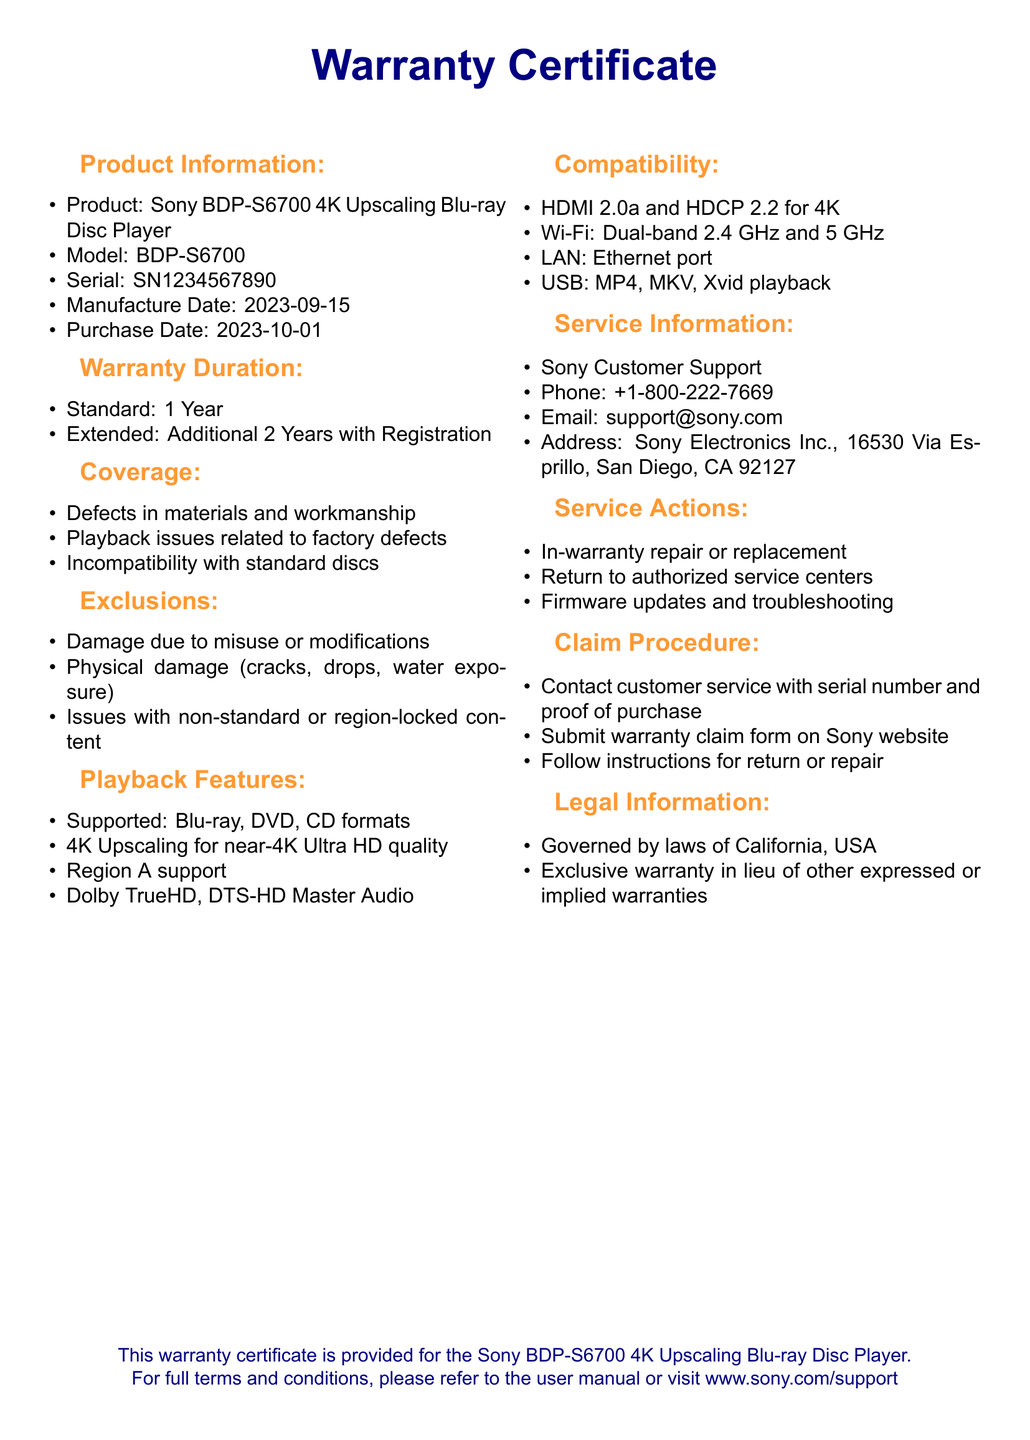What is the product name? The product name is specified in the "Product Information" section as the Sony BDP-S6700 4K Upscaling Blu-ray Disc Player.
Answer: Sony BDP-S6700 4K Upscaling Blu-ray Disc Player What is the warranty duration for the standard warranty? The warranty duration is provided in the "Warranty Duration" section where it states the standard warranty is for 1 year.
Answer: 1 Year What are the playback formats supported by the Blu-ray player? This information is found in the "Playback Features" section, which lists the supported formats as Blu-ray, DVD, and CD.
Answer: Blu-ray, DVD, CD Which audio formats are mentioned in the document? The "Playback Features" section mentions Dolby TrueHD and DTS-HD Master Audio as supported audio formats.
Answer: Dolby TrueHD, DTS-HD Master Audio What is excluded from the warranty coverage? The document lists exclusions in the "Exclusions" section including damage due to misuse or modifications, physical damage, and issues with non-standard content.
Answer: Damage due to misuse or modifications, physical damage, issues with non-standard or region-locked content What is the claim procedure for the warranty? The "Claim Procedure" section details the steps to follow, including contacting customer service, submitting a warranty claim form, and following instructions for return or repair.
Answer: Contact customer service with serial number and proof of purchase, submit warranty claim form on Sony website, follow instructions for return or repair How long is the extended warranty? The "Warranty Duration" section states that the extended warranty is an additional 2 years with registration.
Answer: Additional 2 Years with Registration Which customer support channel is provided? The "Service Information" section includes multiple contact methods, including phone, email, and address for Sony Customer Support.
Answer: Phone: +1-800-222-7669, Email: support@sony.com What types of service actions are available under warranty? The "Service Actions" section outlines the available actions, including in-warranty repair or replacement, return to authorized service centers, and firmware updates.
Answer: In-warranty repair or replacement, return to authorized service centers, firmware updates and troubleshooting 